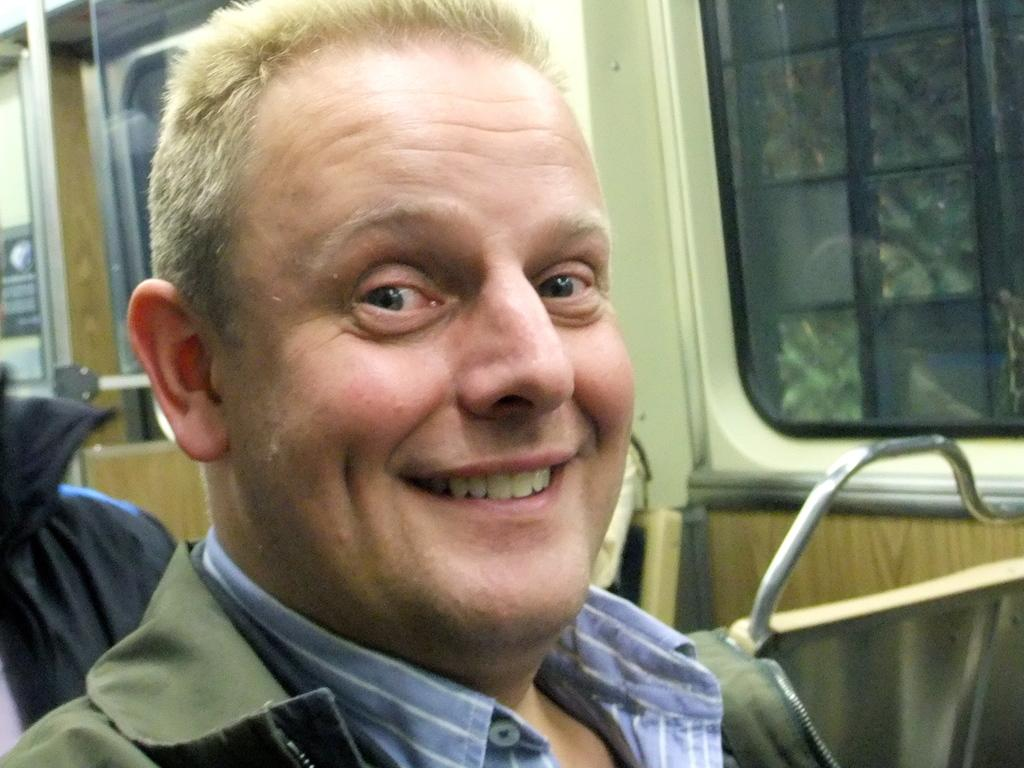What is the main subject of the image? There is a person in the image. What type of setting is depicted in the image? The image appears to depict a train. What can be seen on the right side of the image? There is a window on the right side of the image. Where is the yard with horses located in the image? There is no yard with horses present in the image. What type of mailbox can be seen near the person in the image? There is no mailbox visible in the image. 